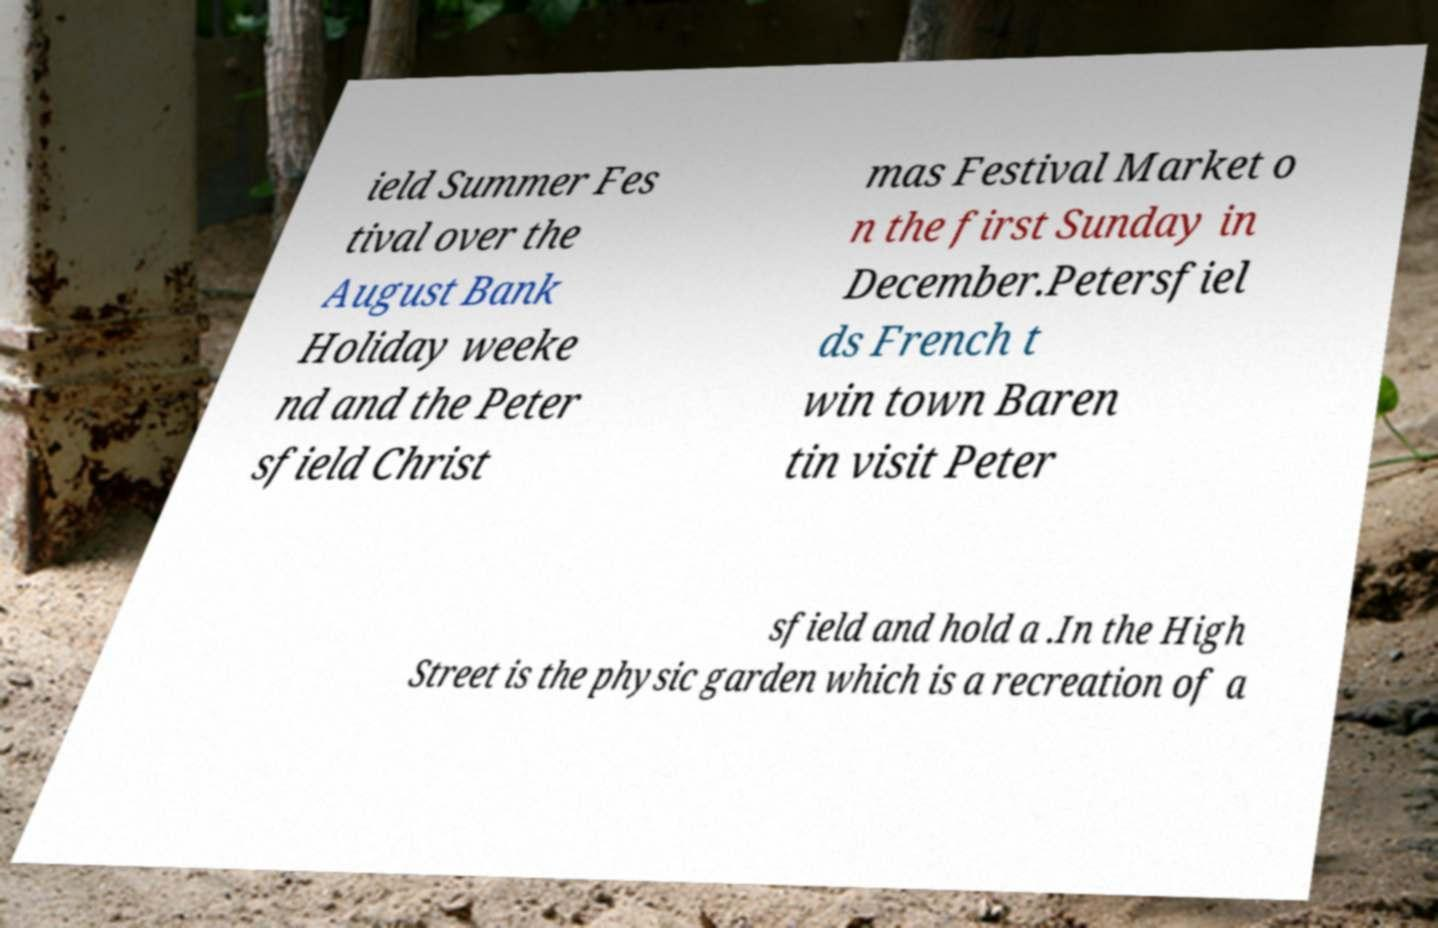Please identify and transcribe the text found in this image. ield Summer Fes tival over the August Bank Holiday weeke nd and the Peter sfield Christ mas Festival Market o n the first Sunday in December.Petersfiel ds French t win town Baren tin visit Peter sfield and hold a .In the High Street is the physic garden which is a recreation of a 